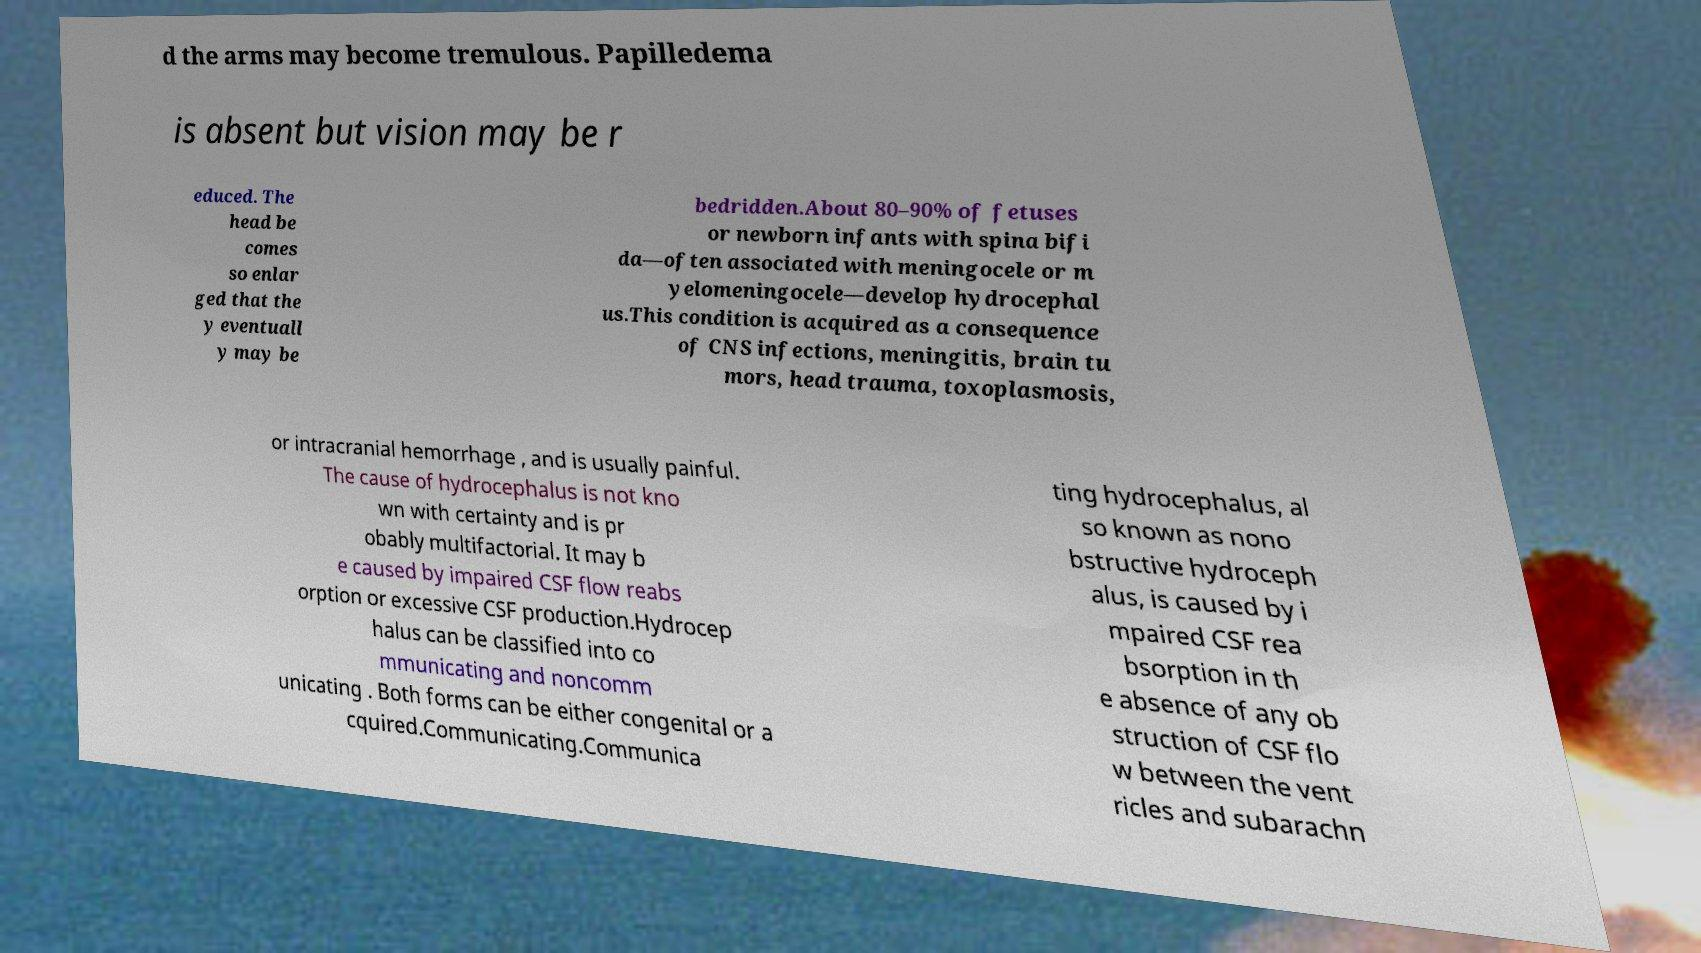Could you assist in decoding the text presented in this image and type it out clearly? d the arms may become tremulous. Papilledema is absent but vision may be r educed. The head be comes so enlar ged that the y eventuall y may be bedridden.About 80–90% of fetuses or newborn infants with spina bifi da—often associated with meningocele or m yelomeningocele—develop hydrocephal us.This condition is acquired as a consequence of CNS infections, meningitis, brain tu mors, head trauma, toxoplasmosis, or intracranial hemorrhage , and is usually painful. The cause of hydrocephalus is not kno wn with certainty and is pr obably multifactorial. It may b e caused by impaired CSF flow reabs orption or excessive CSF production.Hydrocep halus can be classified into co mmunicating and noncomm unicating . Both forms can be either congenital or a cquired.Communicating.Communica ting hydrocephalus, al so known as nono bstructive hydroceph alus, is caused by i mpaired CSF rea bsorption in th e absence of any ob struction of CSF flo w between the vent ricles and subarachn 